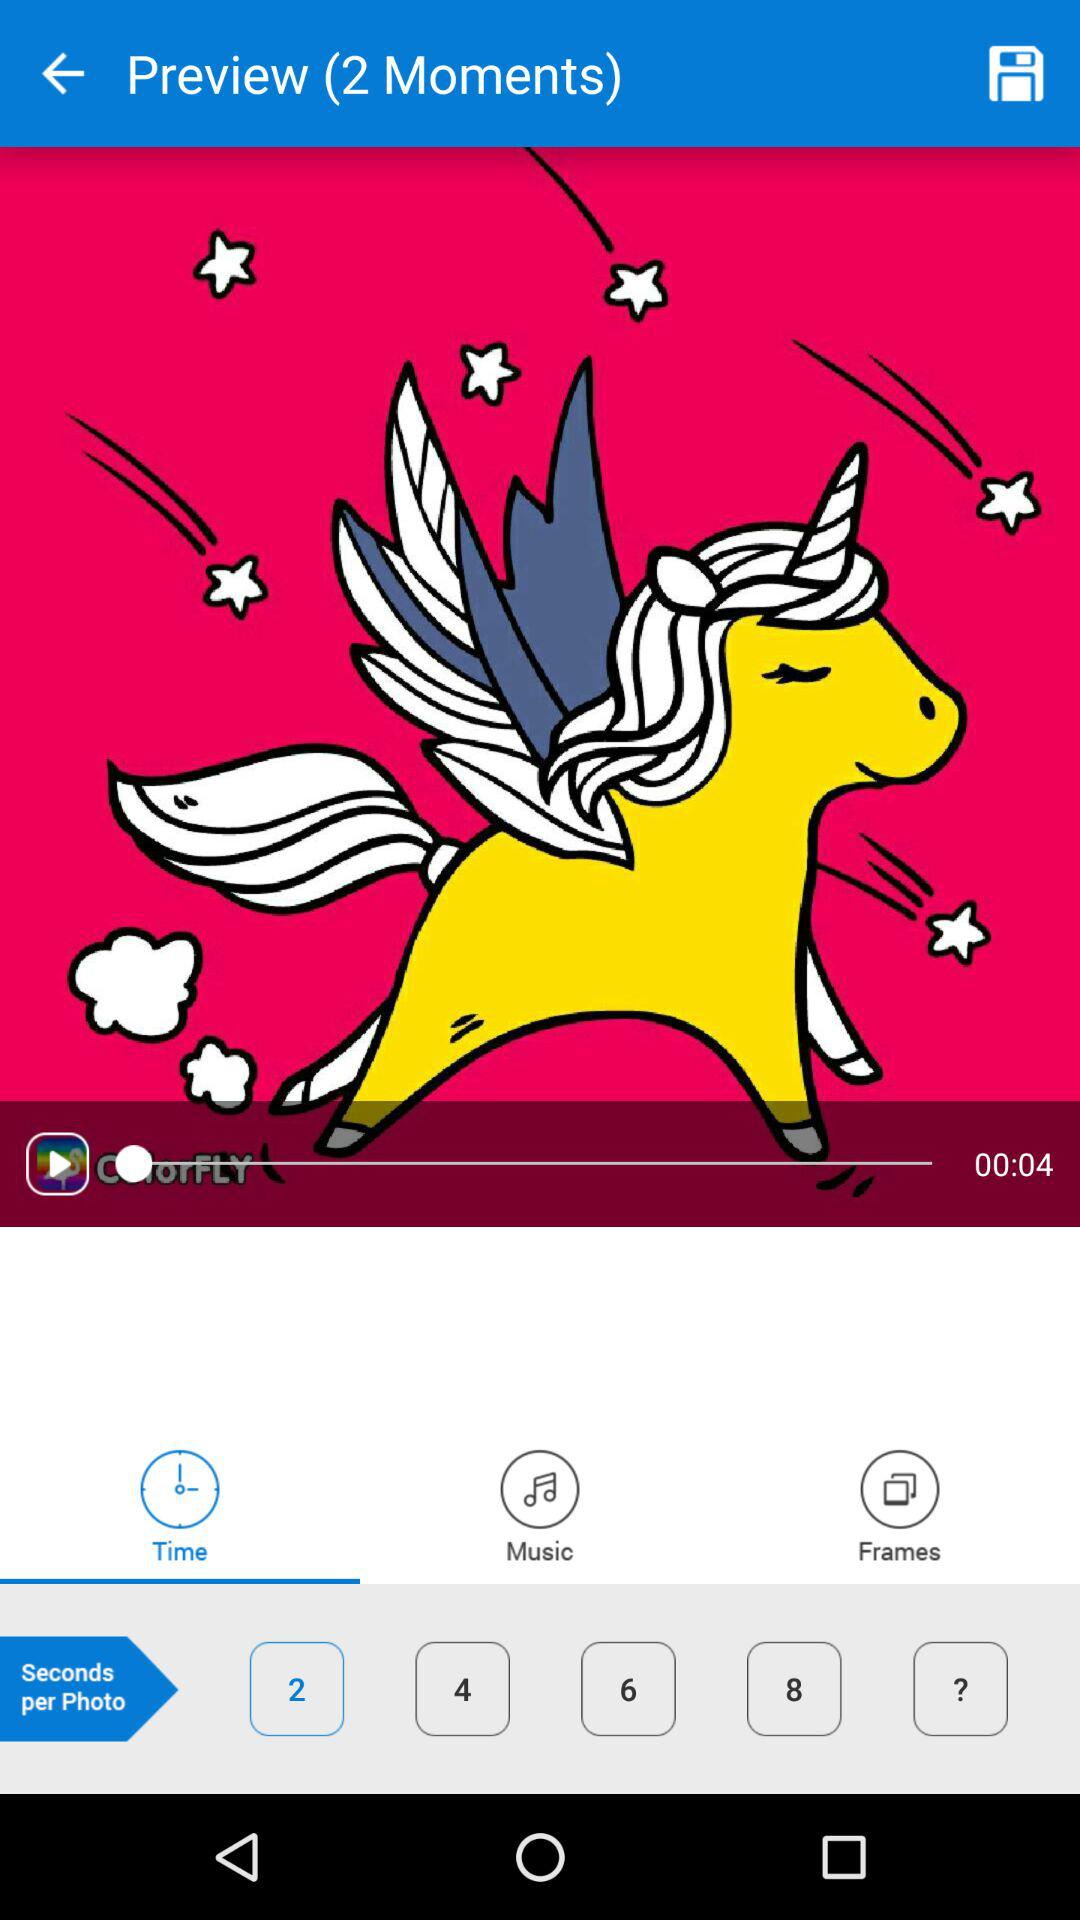How many moments are there in the preview?
Answer the question using a single word or phrase. 2 